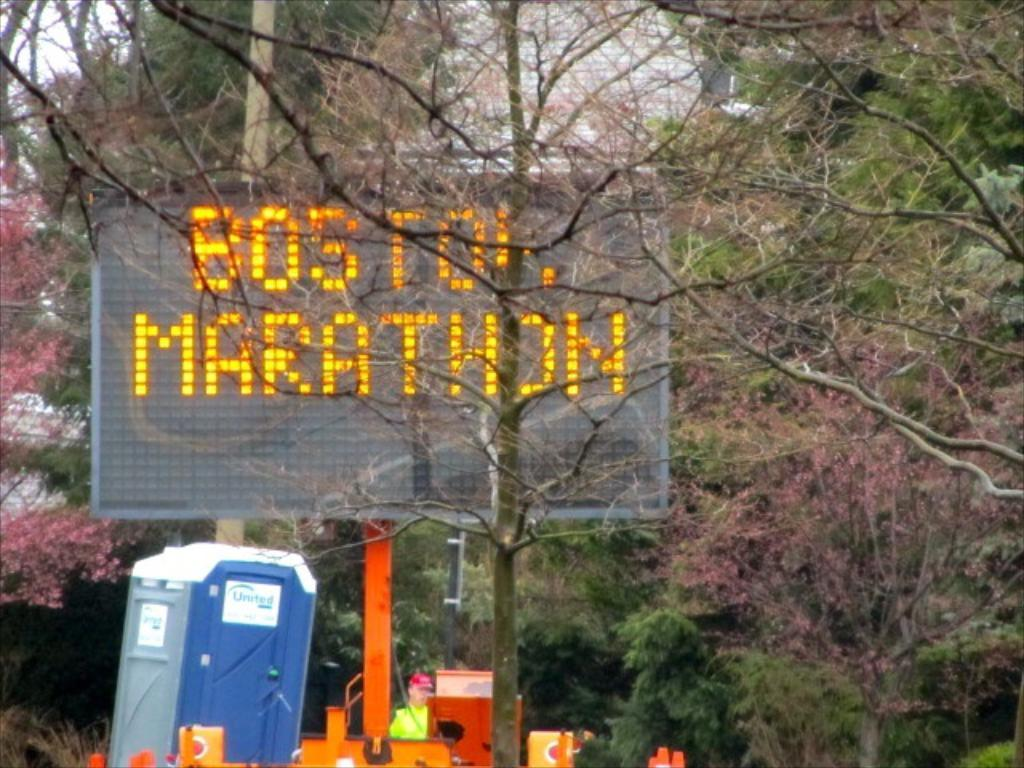<image>
Render a clear and concise summary of the photo. a sign for the Boston Marathon above a port a potty 